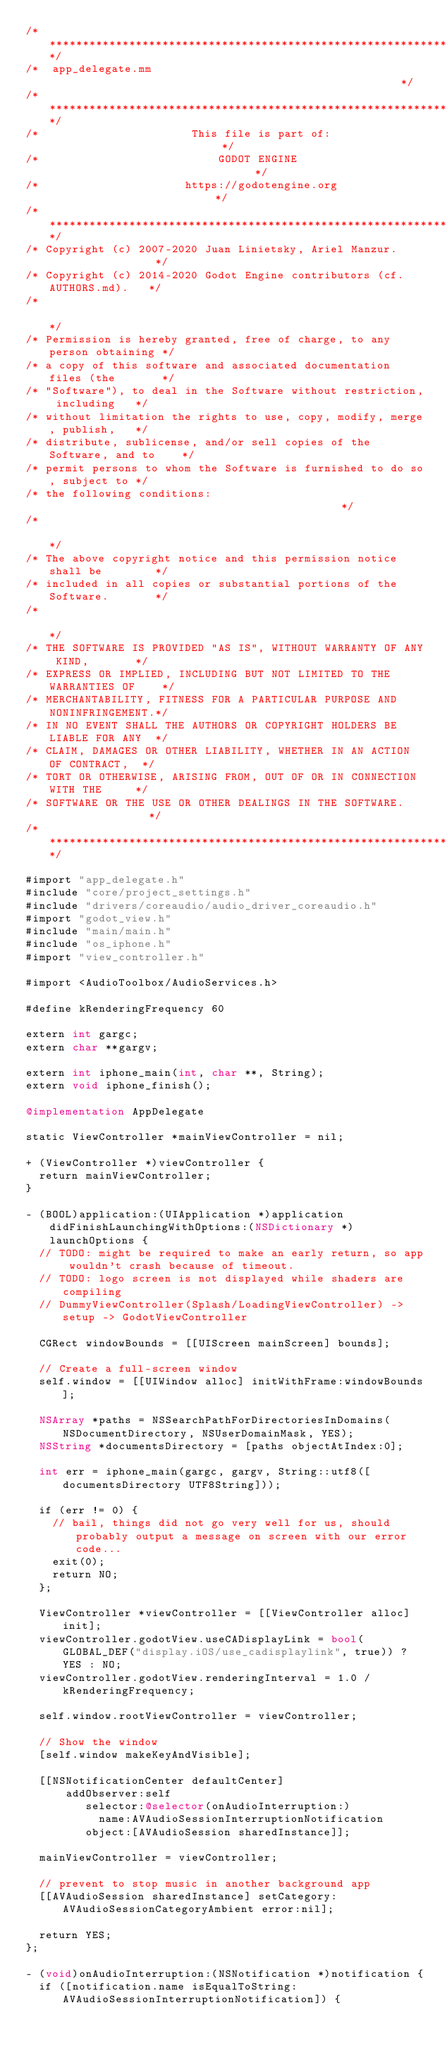<code> <loc_0><loc_0><loc_500><loc_500><_ObjectiveC_>/*************************************************************************/
/*  app_delegate.mm                                                      */
/*************************************************************************/
/*                       This file is part of:                           */
/*                           GODOT ENGINE                                */
/*                      https://godotengine.org                          */
/*************************************************************************/
/* Copyright (c) 2007-2020 Juan Linietsky, Ariel Manzur.                 */
/* Copyright (c) 2014-2020 Godot Engine contributors (cf. AUTHORS.md).   */
/*                                                                       */
/* Permission is hereby granted, free of charge, to any person obtaining */
/* a copy of this software and associated documentation files (the       */
/* "Software"), to deal in the Software without restriction, including   */
/* without limitation the rights to use, copy, modify, merge, publish,   */
/* distribute, sublicense, and/or sell copies of the Software, and to    */
/* permit persons to whom the Software is furnished to do so, subject to */
/* the following conditions:                                             */
/*                                                                       */
/* The above copyright notice and this permission notice shall be        */
/* included in all copies or substantial portions of the Software.       */
/*                                                                       */
/* THE SOFTWARE IS PROVIDED "AS IS", WITHOUT WARRANTY OF ANY KIND,       */
/* EXPRESS OR IMPLIED, INCLUDING BUT NOT LIMITED TO THE WARRANTIES OF    */
/* MERCHANTABILITY, FITNESS FOR A PARTICULAR PURPOSE AND NONINFRINGEMENT.*/
/* IN NO EVENT SHALL THE AUTHORS OR COPYRIGHT HOLDERS BE LIABLE FOR ANY  */
/* CLAIM, DAMAGES OR OTHER LIABILITY, WHETHER IN AN ACTION OF CONTRACT,  */
/* TORT OR OTHERWISE, ARISING FROM, OUT OF OR IN CONNECTION WITH THE     */
/* SOFTWARE OR THE USE OR OTHER DEALINGS IN THE SOFTWARE.                */
/*************************************************************************/

#import "app_delegate.h"
#include "core/project_settings.h"
#include "drivers/coreaudio/audio_driver_coreaudio.h"
#import "godot_view.h"
#include "main/main.h"
#include "os_iphone.h"
#import "view_controller.h"

#import <AudioToolbox/AudioServices.h>

#define kRenderingFrequency 60

extern int gargc;
extern char **gargv;

extern int iphone_main(int, char **, String);
extern void iphone_finish();

@implementation AppDelegate

static ViewController *mainViewController = nil;

+ (ViewController *)viewController {
	return mainViewController;
}

- (BOOL)application:(UIApplication *)application didFinishLaunchingWithOptions:(NSDictionary *)launchOptions {
	// TODO: might be required to make an early return, so app wouldn't crash because of timeout.
	// TODO: logo screen is not displayed while shaders are compiling
	// DummyViewController(Splash/LoadingViewController) -> setup -> GodotViewController

	CGRect windowBounds = [[UIScreen mainScreen] bounds];

	// Create a full-screen window
	self.window = [[UIWindow alloc] initWithFrame:windowBounds];

	NSArray *paths = NSSearchPathForDirectoriesInDomains(NSDocumentDirectory, NSUserDomainMask, YES);
	NSString *documentsDirectory = [paths objectAtIndex:0];

	int err = iphone_main(gargc, gargv, String::utf8([documentsDirectory UTF8String]));

	if (err != 0) {
		// bail, things did not go very well for us, should probably output a message on screen with our error code...
		exit(0);
		return NO;
	};

	ViewController *viewController = [[ViewController alloc] init];
	viewController.godotView.useCADisplayLink = bool(GLOBAL_DEF("display.iOS/use_cadisplaylink", true)) ? YES : NO;
	viewController.godotView.renderingInterval = 1.0 / kRenderingFrequency;

	self.window.rootViewController = viewController;

	// Show the window
	[self.window makeKeyAndVisible];

	[[NSNotificationCenter defaultCenter]
			addObserver:self
			   selector:@selector(onAudioInterruption:)
				   name:AVAudioSessionInterruptionNotification
				 object:[AVAudioSession sharedInstance]];

	mainViewController = viewController;

	// prevent to stop music in another background app
	[[AVAudioSession sharedInstance] setCategory:AVAudioSessionCategoryAmbient error:nil];

	return YES;
};

- (void)onAudioInterruption:(NSNotification *)notification {
	if ([notification.name isEqualToString:AVAudioSessionInterruptionNotification]) {</code> 